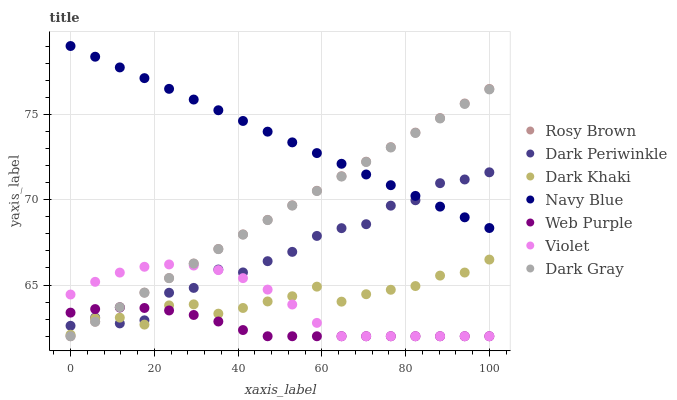Does Web Purple have the minimum area under the curve?
Answer yes or no. Yes. Does Navy Blue have the maximum area under the curve?
Answer yes or no. Yes. Does Rosy Brown have the minimum area under the curve?
Answer yes or no. No. Does Rosy Brown have the maximum area under the curve?
Answer yes or no. No. Is Dark Gray the smoothest?
Answer yes or no. Yes. Is Dark Periwinkle the roughest?
Answer yes or no. Yes. Is Navy Blue the smoothest?
Answer yes or no. No. Is Navy Blue the roughest?
Answer yes or no. No. Does Dark Gray have the lowest value?
Answer yes or no. Yes. Does Navy Blue have the lowest value?
Answer yes or no. No. Does Navy Blue have the highest value?
Answer yes or no. Yes. Does Rosy Brown have the highest value?
Answer yes or no. No. Is Dark Khaki less than Navy Blue?
Answer yes or no. Yes. Is Navy Blue greater than Violet?
Answer yes or no. Yes. Does Dark Periwinkle intersect Web Purple?
Answer yes or no. Yes. Is Dark Periwinkle less than Web Purple?
Answer yes or no. No. Is Dark Periwinkle greater than Web Purple?
Answer yes or no. No. Does Dark Khaki intersect Navy Blue?
Answer yes or no. No. 